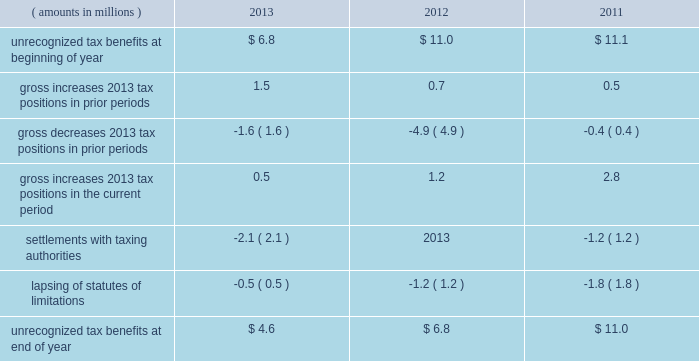A valuation allowance totaling $ 45.4 million , $ 43.9 million and $ 40.4 million as of 2013 , 2012 and 2011 year end , respectively , has been established for deferred income tax assets primarily related to certain subsidiary loss carryforwards that may not be realized .
Realization of the net deferred income tax assets is dependent on generating sufficient taxable income prior to their expiration .
Although realization is not assured , management believes it is more- likely-than-not that the net deferred income tax assets will be realized .
The amount of the net deferred income tax assets considered realizable , however , could change in the near term if estimates of future taxable income during the carryforward period fluctuate .
The following is a reconciliation of the beginning and ending amounts of unrecognized tax benefits for 2013 , 2012 and ( amounts in millions ) 2013 2012 2011 .
Of the $ 4.6 million , $ 6.8 million and $ 11.0 million of unrecognized tax benefits as of 2013 , 2012 and 2011 year end , respectively , approximately $ 4.6 million , $ 4.1 million and $ 9.1 million , respectively , would impact the effective income tax rate if recognized .
Interest and penalties related to unrecognized tax benefits are recorded in income tax expense .
During 2013 and 2012 , the company reversed a net $ 0.6 million and $ 0.5 million , respectively , of interest and penalties to income associated with unrecognized tax benefits .
As of 2013 , 2012 and 2011 year end , the company has provided for $ 0.9 million , $ 1.6 million and $ 1.6 million , respectively , of accrued interest and penalties related to unrecognized tax benefits .
The unrecognized tax benefits and related accrued interest and penalties are included in 201cother long-term liabilities 201d on the accompanying consolidated balance sheets .
Snap-on and its subsidiaries file income tax returns in the united states and in various state , local and foreign jurisdictions .
It is reasonably possible that certain unrecognized tax benefits may either be settled with taxing authorities or the statutes of limitations for such items may lapse within the next 12 months , causing snap-on 2019s gross unrecognized tax benefits to decrease by a range of zero to $ 1.1 million .
Over the next 12 months , snap-on anticipates taking certain tax positions on various tax returns for which the related tax benefit does not meet the recognition threshold .
Accordingly , snap-on 2019s gross unrecognized tax benefits may increase by a range of zero to $ 0.8 million over the next 12 months for uncertain tax positions expected to be taken in future tax filings .
With few exceptions , snap-on is no longer subject to u.s .
Federal and state/local income tax examinations by tax authorities for years prior to 2008 , and snap-on is no longer subject to non-u.s .
Income tax examinations by tax authorities for years prior to 2006 .
The undistributed earnings of all non-u.s .
Subsidiaries totaled $ 556.0 million , $ 492.2 million and $ 416.4 million as of 2013 , 2012 and 2011 year end , respectively .
Snap-on has not provided any deferred taxes on these undistributed earnings as it considers the undistributed earnings to be permanently invested .
Determination of the amount of unrecognized deferred income tax liability related to these earnings is not practicable .
2013 annual report 83 .
What percent of unrecognized tax benefits as of 2012 would not impact the effective income tax rate if recognized? 
Computations: ((6.8 - 4.1) / 6.8)
Answer: 0.39706. 